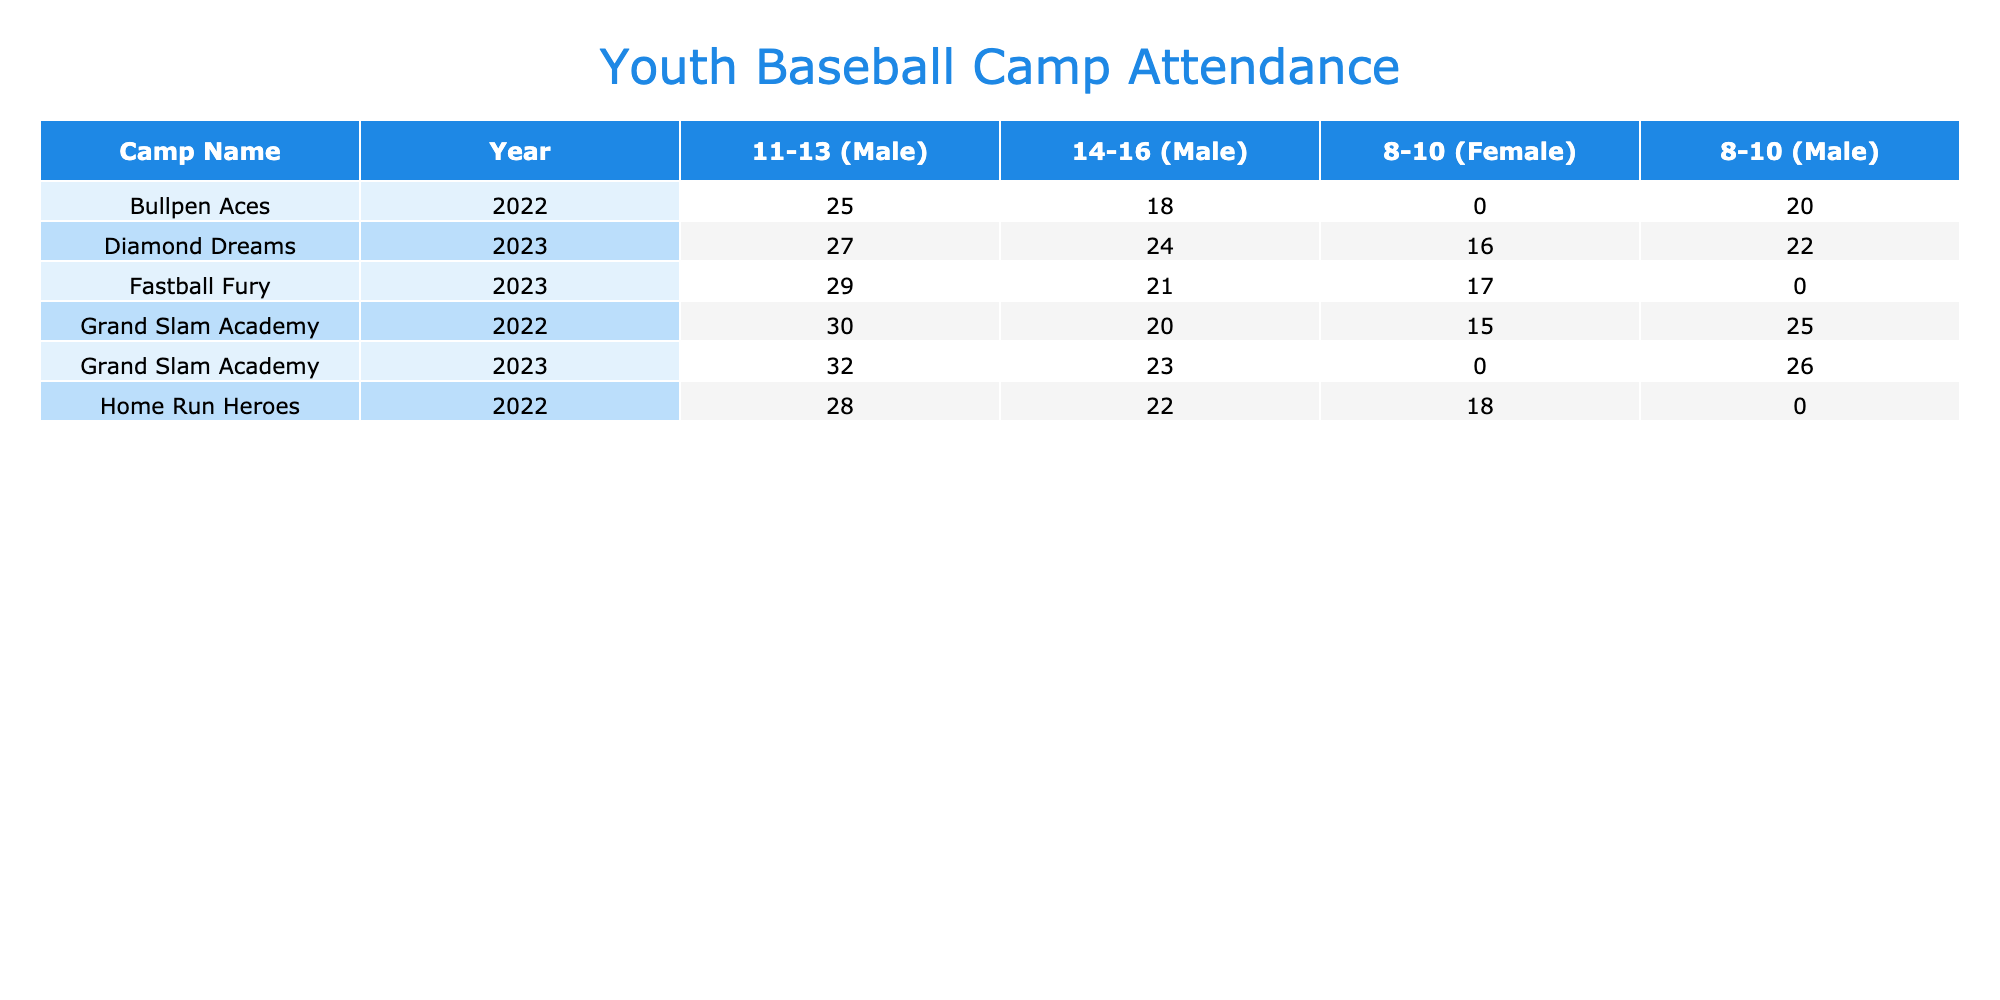What is the total number of participants in the Grand Slam Academy for 2022? There are three age groups for Grand Slam Academy in 2022: 8-10 (25 participants), 11-13 (30 participants), and 14-16 (20 participants). Adding them together gives 25 + 30 + 20 = 75.
Answer: 75 Which camp had the highest participation from female participants in 2023? In 2023, the participants from Diamond Dreams (16 participants in the 8-10 age group) and Fastball Fury (17 participants in the 8-10 age group) are both counted. Fastball Fury has the higher number of female participants with 17 total.
Answer: Fastball Fury How many male participants were present in the Home Run Heroes camp? There are two rows for Home Run Heroes; the age groups are 11-13 with 28 participants and 14-16 with 22 participants. Adding those groups gives 28 + 22 = 50 male participants.
Answer: 50 Is there a youth camp in New York that had an advanced skill level in 2023? The table shows that Diamond Dreams in New York had 24 male participants in the 14-16 age group, which indicates that it had an advanced skill level in 2023.
Answer: Yes What is the difference in male participants between the Grand Slam Academy's 11-13 age group in 2022 and 2023? The Grand Slam Academy had 30 male participants in the 11-13 age group in 2022 and 32 in 2023. The difference is calculated as 32 - 30 = 2.
Answer: 2 What is the total number of participants for all camps in Chicago across both years? Grand Slam Academy had 75 participants in 2022 and 81 participants in 2023 (26 + 32 + 23 = 81). Adding those totals gives 75 + 81 = 156 participants in Chicago across both years.
Answer: 156 How many participants were there at the Bullpen Aces camp in June 2022 for the 8-10 age group? The Bullpen Aces had 20 male participants in the 8-10 age group in June 2022.
Answer: 20 Was the attendance at the Home Run Heroes camp in July 2022 higher than at the Diamond Dreams camp in July 2023? Home Run Heroes had 22 male participants in July 2022, while Diamond Dreams had 24 male participants in July 2023. Since 24 is greater than 22, the attendance at Diamond Dreams was higher.
Answer: Yes 